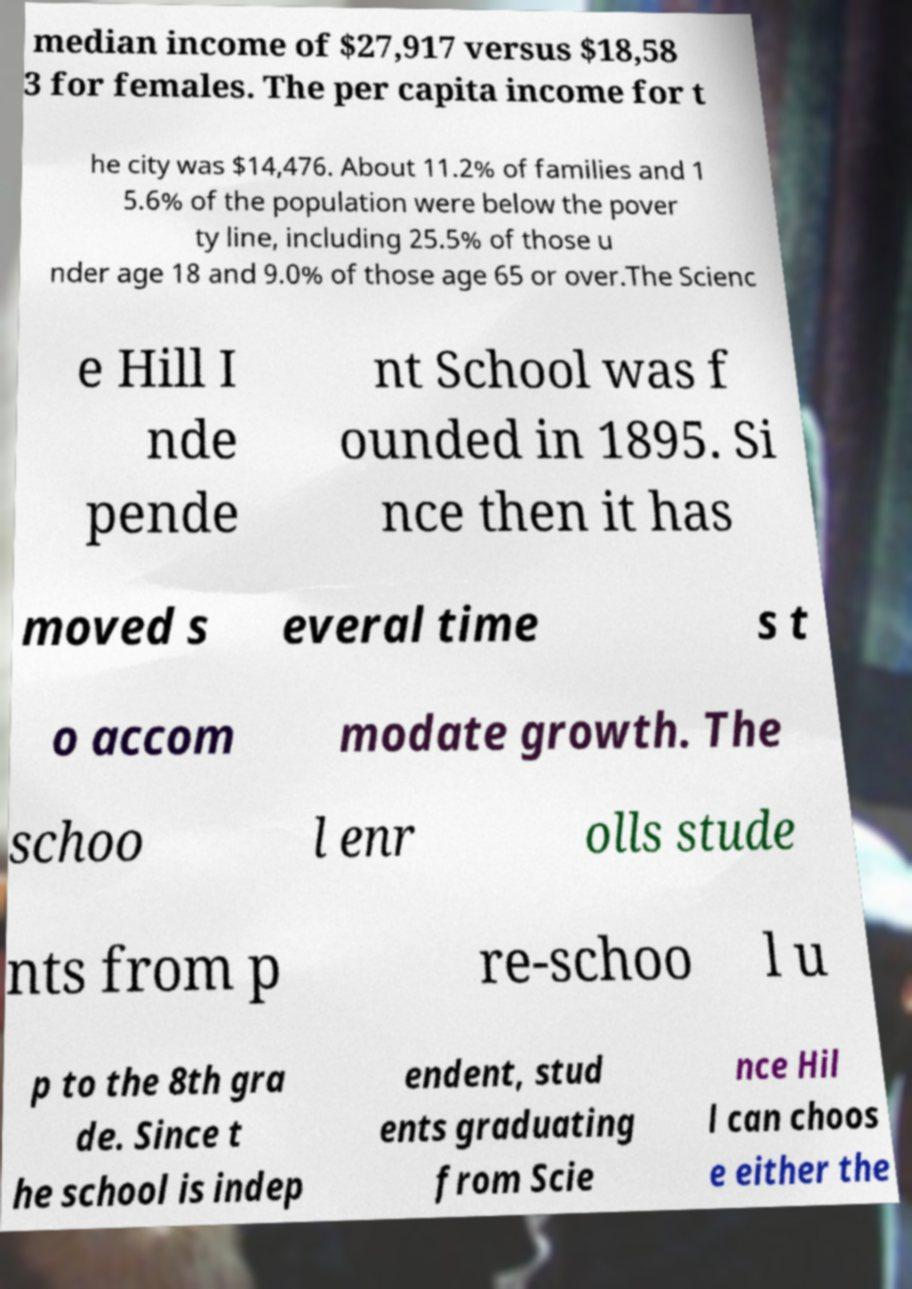There's text embedded in this image that I need extracted. Can you transcribe it verbatim? median income of $27,917 versus $18,58 3 for females. The per capita income for t he city was $14,476. About 11.2% of families and 1 5.6% of the population were below the pover ty line, including 25.5% of those u nder age 18 and 9.0% of those age 65 or over.The Scienc e Hill I nde pende nt School was f ounded in 1895. Si nce then it has moved s everal time s t o accom modate growth. The schoo l enr olls stude nts from p re-schoo l u p to the 8th gra de. Since t he school is indep endent, stud ents graduating from Scie nce Hil l can choos e either the 